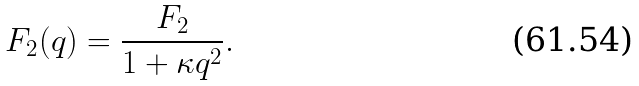<formula> <loc_0><loc_0><loc_500><loc_500>F _ { 2 } ( { q } ) = \frac { F _ { 2 } } { 1 + \kappa q ^ { 2 } } .</formula> 